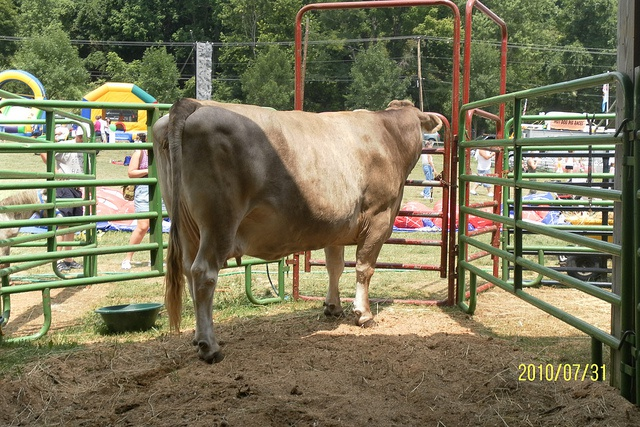Describe the objects in this image and their specific colors. I can see cow in olive, gray, and black tones, people in olive, white, tan, black, and salmon tones, people in olive, white, gray, darkgray, and tan tones, bowl in olive, black, teal, darkgray, and darkgreen tones, and people in olive, white, darkgray, and tan tones in this image. 